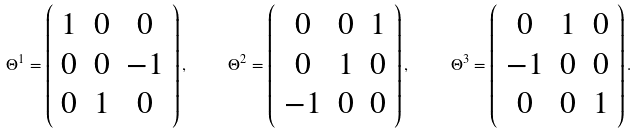<formula> <loc_0><loc_0><loc_500><loc_500>\Theta ^ { 1 } = \left ( \begin{array} { c c c } 1 & 0 & 0 \\ 0 & 0 & - 1 \\ 0 & 1 & 0 \end{array} \right ) , \quad \ \Theta ^ { 2 } = \left ( \begin{array} { c c c } 0 & 0 & 1 \\ 0 & 1 & 0 \\ - 1 & 0 & 0 \end{array} \right ) , \quad \ \Theta ^ { 3 } = \left ( \begin{array} { c c c } 0 & 1 & 0 \\ - 1 & 0 & 0 \\ 0 & 0 & 1 \end{array} \right ) .</formula> 